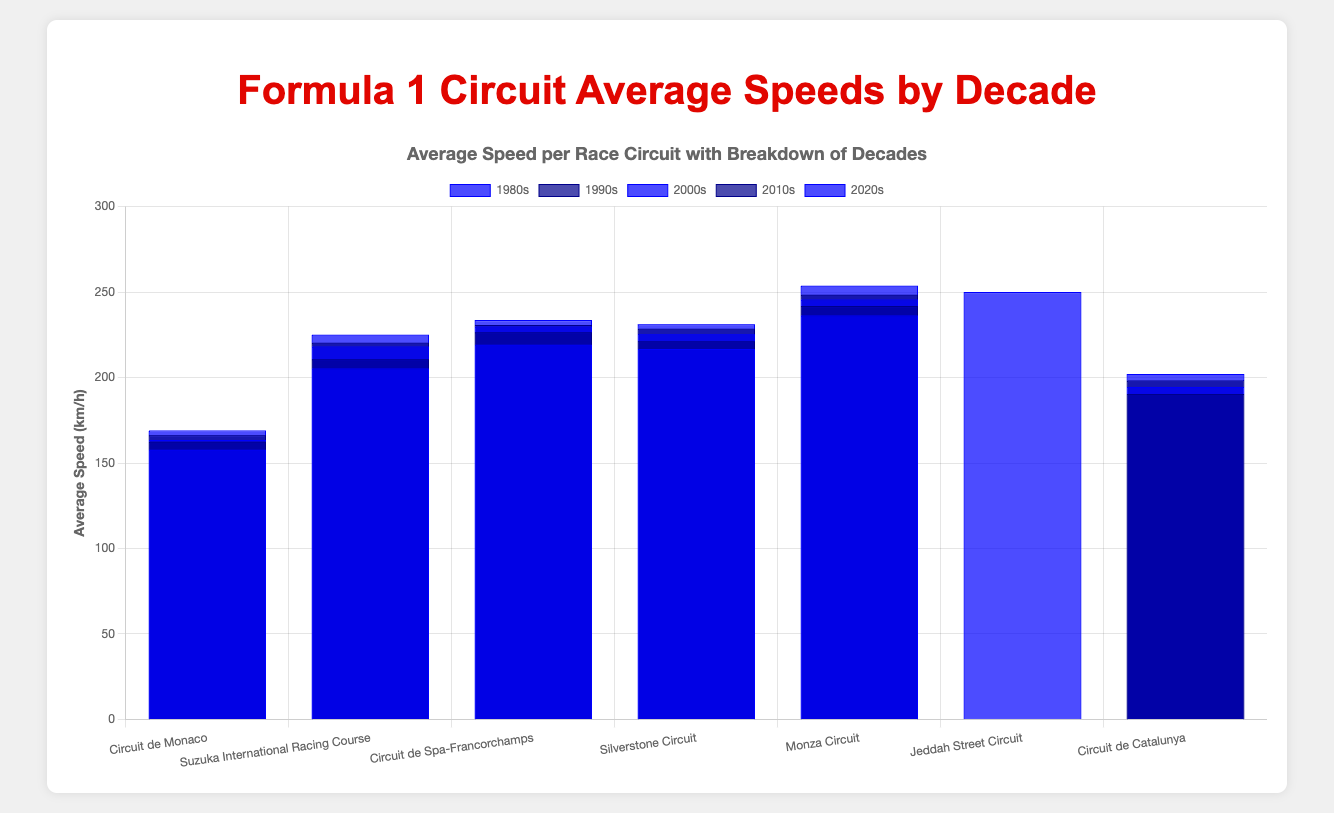What is the average speed for Circuit de Spa-Francorchamps in the 2000s? Look at the bar representing Circuit de Spa-Francorchamps in the 2000s; it's labeled with the speed.
Answer: 229.8 km/h By how many km/h did the average speed for the Monza Circuit increase from the 1980s to the 2020s? Look at the speeds for Monza Circuit in the 1980s and 2020s: 253.7 km/h (2020s) - 236.3 km/h (1980s) = 17.4 km/h
Answer: 17.4 km/h Which circuit had the highest average speed in the 2020s? Compare the heights of the bars for each circuit in the 2020s. Monza Circuit's bar is the highest in that decade.
Answer: Monza Circuit How did the average speed at Circuit de Monaco change from the 1980s to the 2020s? Look at the bars for Circuit de Monaco in the 1980s and 2020s: 169.0 km/h (2020s) - 157.8 km/h (1980s) = 11.2 km/h
Answer: Increased by 11.2 km/h What was the total average speed across all displayed decades for Suzuka International Racing Course? Sum the average speeds for each decade displayed for Suzuka International Racing Course: 205.3 + 210.7 + 218.1 + 220.3 + 225.0
Answer: 1079.4 km/h Which circuit had the lowest average speed in the 1990s? Compare the bars for each circuit in the 1990s. Circuit de Monaco's bar is the shortest in that decade.
Answer: Circuit de Monaco How does the average speed of Jeddah Street Circuit in the 2020s compare with Circuit de Catalunya in the same decade? Compare the heights of the bars for Jeddah Street Circuit and Circuit de Catalunya in the 2020s. Jeddah Street Circuit's speed is higher.
Answer: Jeddah Street Circuit is higher What is the combined average speed of Silverstone Circuit and Circuit de Catalunya in the 2020s? Sum the average speeds for Silverstone Circuit and Circuit de Catalunya in the 2020s: 231.2 + 202.1
Answer: 433.3 km/h Which decade saw the largest increase in average speed for the Circuit de Spa-Francorchamps? Calculate the increase in speed for each decade transition: 
  - 1980s to 1990s: 226.5 - 219.2 = 7.3 km/h
  - 1990s to 2000s: 229.8 - 226.5 = 3.3 km/h
  - 2000s to 2010s: 230.7 - 229.8 = 0.9 km/h
  - 2010s to 2020s: 233.6 - 230.7 = 2.9 km/h
  The largest increase is from the 1980s to the 1990s.
Answer: 1980s to 1990s How does the average speed for the Circuit de Monaco in the 2000s compare to the average speed for Suzuka International Racing Course in the same decade? Compare the heights of the bars for Circuit de Monaco and Suzuka International Racing Course in the 2000s. Suzuka's speed is higher.
Answer: Suzuka International Racing Course is higher 